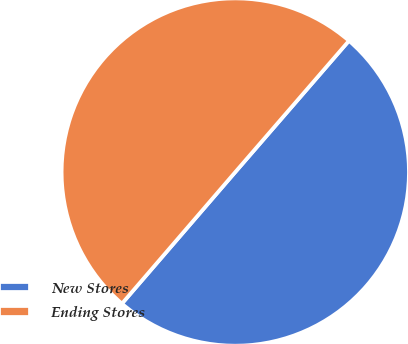<chart> <loc_0><loc_0><loc_500><loc_500><pie_chart><fcel>New Stores<fcel>Ending Stores<nl><fcel>49.96%<fcel>50.04%<nl></chart> 